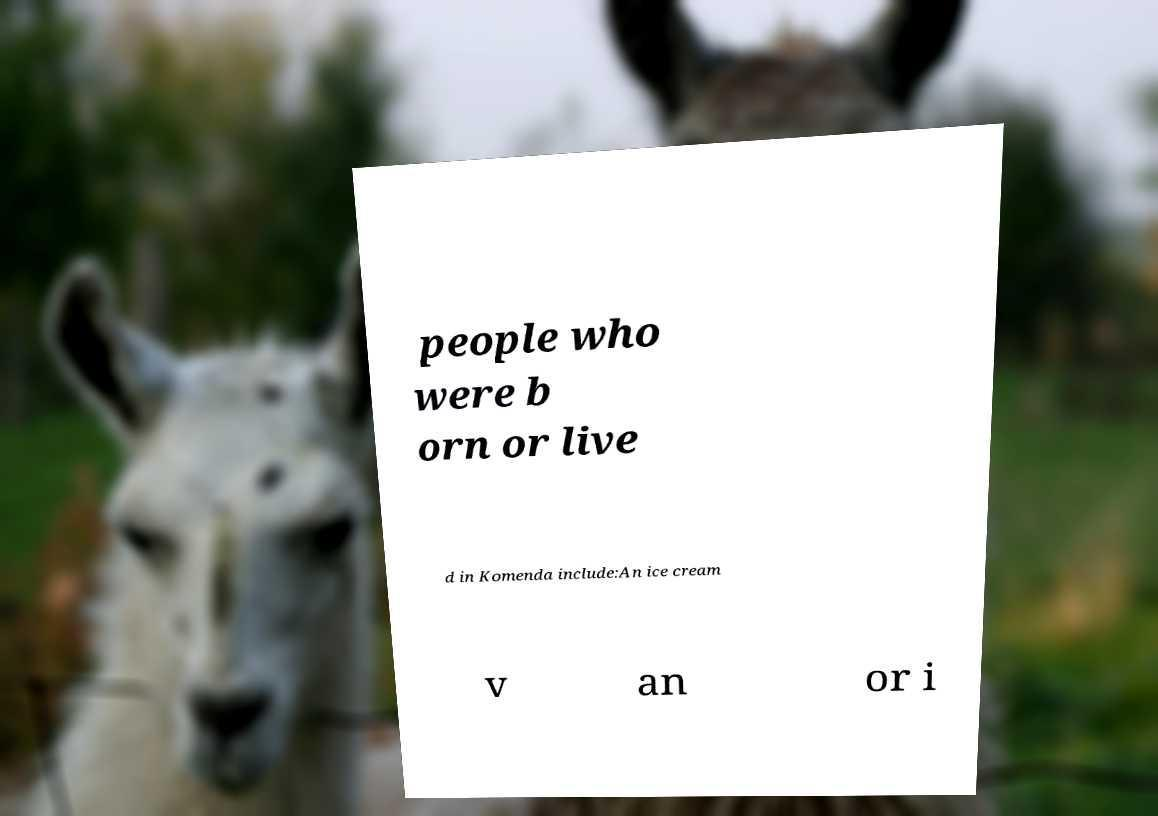There's text embedded in this image that I need extracted. Can you transcribe it verbatim? people who were b orn or live d in Komenda include:An ice cream v an or i 